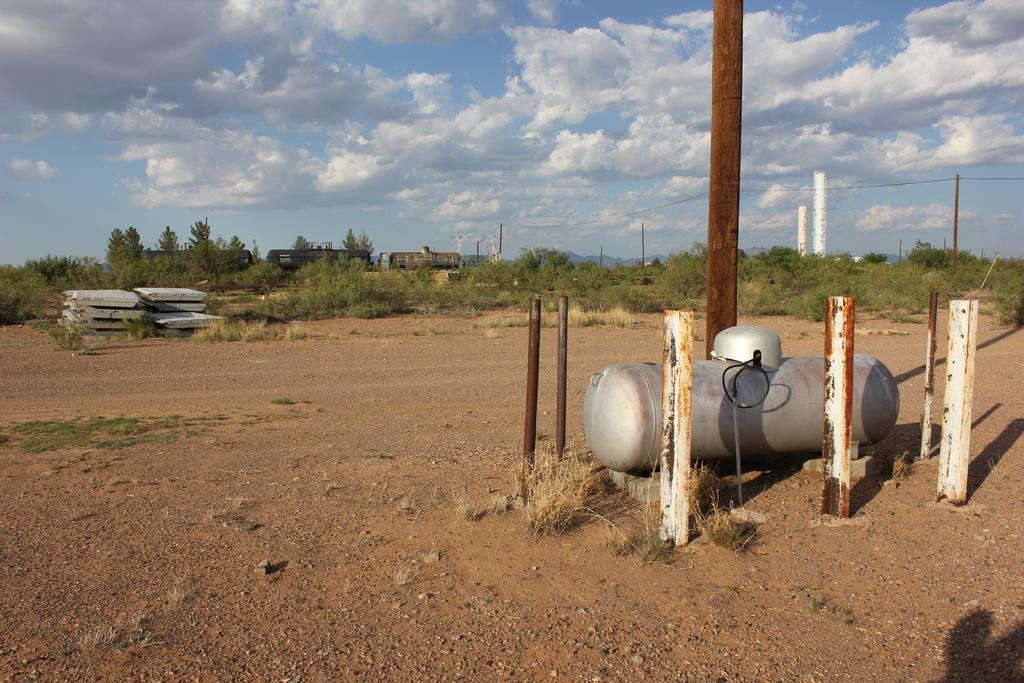Describe this image in one or two sentences. There is an open land and there are plenty of trees and plants around the land. In between there is a pole and beside the pole there is a tank like machine and there are small iron rods are kept around that machine. 